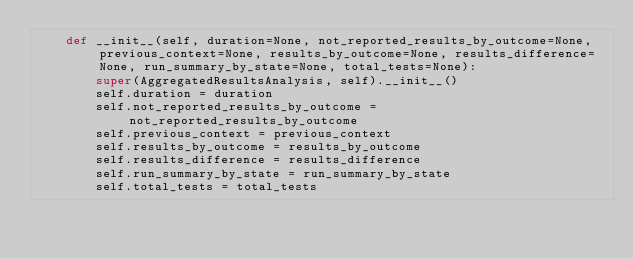<code> <loc_0><loc_0><loc_500><loc_500><_Python_>    def __init__(self, duration=None, not_reported_results_by_outcome=None, previous_context=None, results_by_outcome=None, results_difference=None, run_summary_by_state=None, total_tests=None):
        super(AggregatedResultsAnalysis, self).__init__()
        self.duration = duration
        self.not_reported_results_by_outcome = not_reported_results_by_outcome
        self.previous_context = previous_context
        self.results_by_outcome = results_by_outcome
        self.results_difference = results_difference
        self.run_summary_by_state = run_summary_by_state
        self.total_tests = total_tests
</code> 